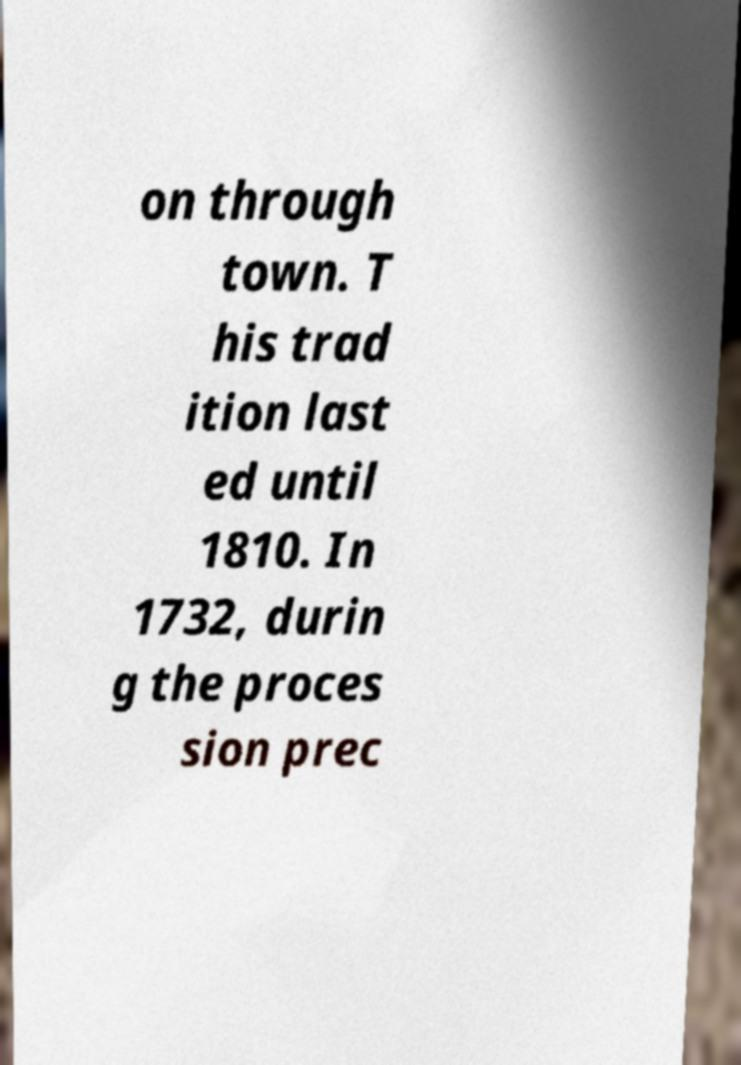For documentation purposes, I need the text within this image transcribed. Could you provide that? on through town. T his trad ition last ed until 1810. In 1732, durin g the proces sion prec 